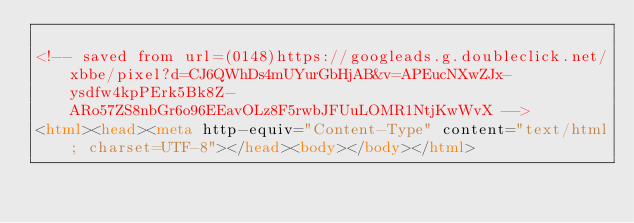<code> <loc_0><loc_0><loc_500><loc_500><_HTML_>
<!-- saved from url=(0148)https://googleads.g.doubleclick.net/xbbe/pixel?d=CJ6QWhDs4mUYurGbHjAB&v=APEucNXwZJx-ysdfw4kpPErk5Bk8Z-ARo57ZS8nbGr6o96EEavOLz8F5rwbJFUuLOMR1NtjKwWvX -->
<html><head><meta http-equiv="Content-Type" content="text/html; charset=UTF-8"></head><body></body></html></code> 